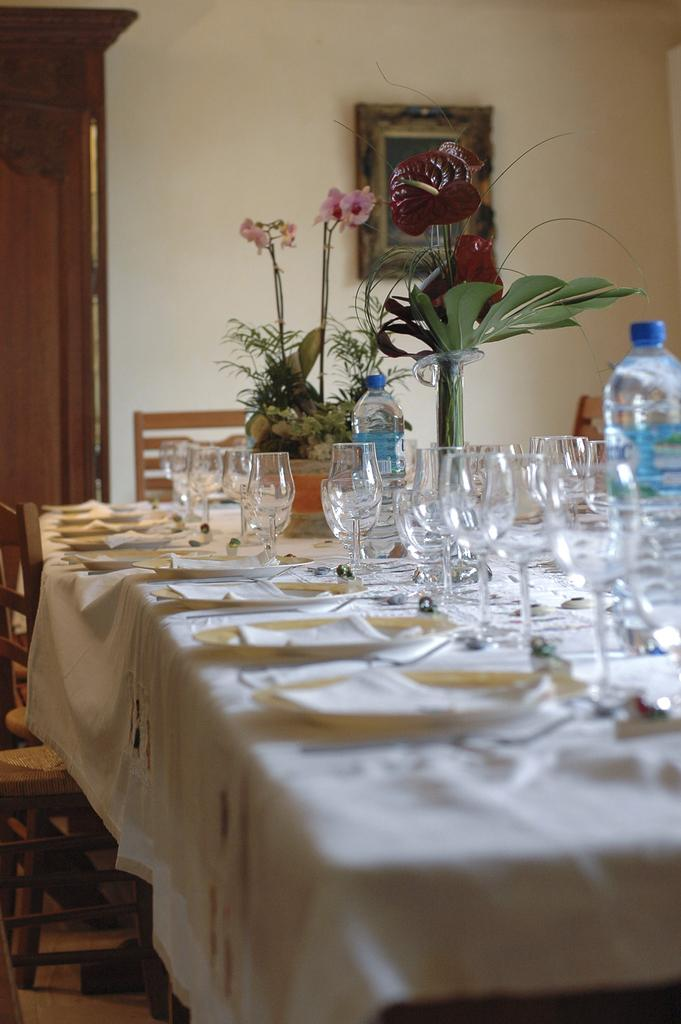What is the color of the wall in the image? The wall in the image is white. What piece of furniture is present in the image? There is a table in the image. What objects are on the table? There are plates, glasses, a bottle, and a flask on the table. What is covering the table in the image? There is a white color cloth on the table. How many horses can be seen in the image? There are no horses present in the image. 